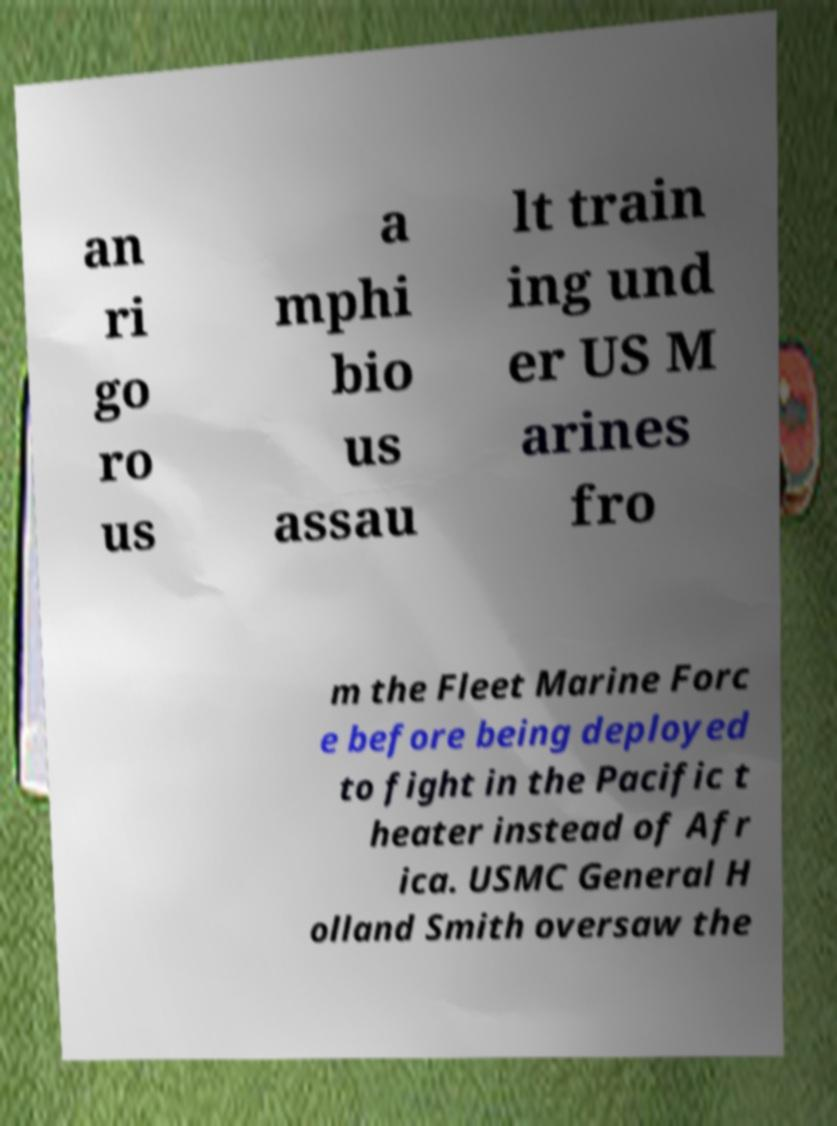There's text embedded in this image that I need extracted. Can you transcribe it verbatim? an ri go ro us a mphi bio us assau lt train ing und er US M arines fro m the Fleet Marine Forc e before being deployed to fight in the Pacific t heater instead of Afr ica. USMC General H olland Smith oversaw the 